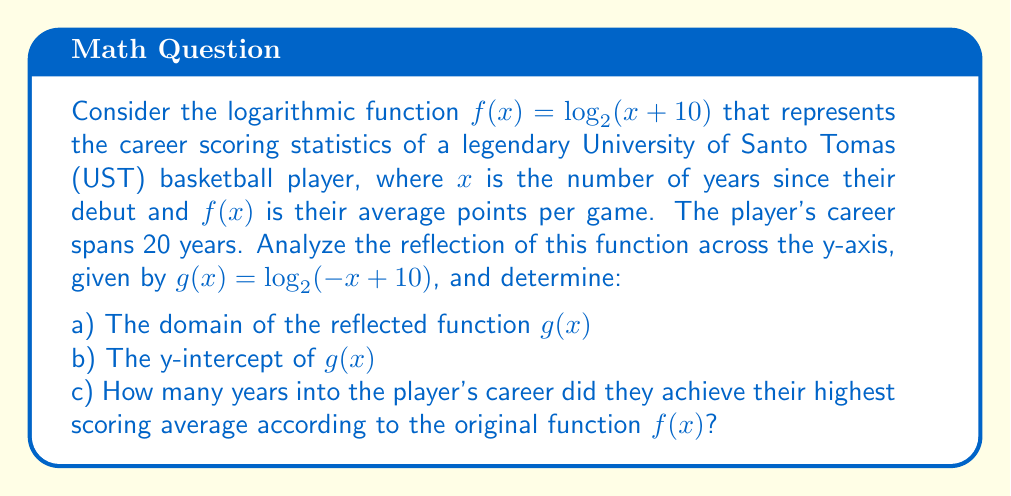Can you solve this math problem? Let's analyze this problem step by step:

a) To find the domain of $g(x) = \log_2(-x + 10)$:
   The argument of a logarithm must be positive, so:
   $-x + 10 > 0$
   $-x > -10$
   $x < 10$
   Therefore, the domain of $g(x)$ is $(-\infty, 10)$.

b) To find the y-intercept of $g(x)$, we set $x = 0$:
   $g(0) = \log_2(-0 + 10) = \log_2(10) \approx 3.32$

c) For the original function $f(x) = \log_2(x + 10)$:
   The domain is $x > -10$, which includes the player's entire 20-year career.
   As $x$ increases, $f(x)$ increases, meaning the scoring average steadily improved over the player's career.
   The highest scoring average would be achieved at the end of their career, which is at $x = 20$.

[asy]
import graph;
size(200,200);
real f(real x) {return log(x+10)/log(2);}
real g(real x) {return log(-x+10)/log(2);}
draw(graph(f,-9.9,20),blue);
draw(graph(g,-20,9.9),red);
xaxis("x",-10,20,arrow=Arrow);
yaxis("y",-1,5,arrow=Arrow);
label("f(x)",(-5,f(-5)),NE,blue);
label("g(x)",(5,g(5)),NW,red);
[/asy]
Answer: a) Domain of $g(x)$: $(-\infty, 10)$
b) y-intercept of $g(x)$: $\log_2(10) \approx 3.32$
c) 20 years (at the end of their career) 